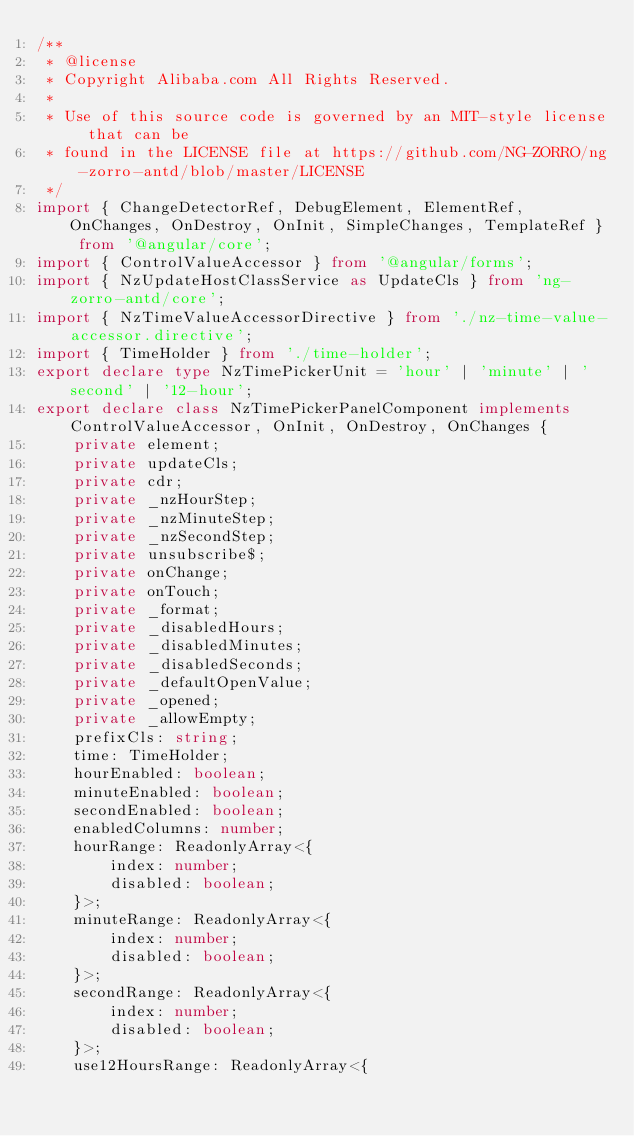<code> <loc_0><loc_0><loc_500><loc_500><_TypeScript_>/**
 * @license
 * Copyright Alibaba.com All Rights Reserved.
 *
 * Use of this source code is governed by an MIT-style license that can be
 * found in the LICENSE file at https://github.com/NG-ZORRO/ng-zorro-antd/blob/master/LICENSE
 */
import { ChangeDetectorRef, DebugElement, ElementRef, OnChanges, OnDestroy, OnInit, SimpleChanges, TemplateRef } from '@angular/core';
import { ControlValueAccessor } from '@angular/forms';
import { NzUpdateHostClassService as UpdateCls } from 'ng-zorro-antd/core';
import { NzTimeValueAccessorDirective } from './nz-time-value-accessor.directive';
import { TimeHolder } from './time-holder';
export declare type NzTimePickerUnit = 'hour' | 'minute' | 'second' | '12-hour';
export declare class NzTimePickerPanelComponent implements ControlValueAccessor, OnInit, OnDestroy, OnChanges {
    private element;
    private updateCls;
    private cdr;
    private _nzHourStep;
    private _nzMinuteStep;
    private _nzSecondStep;
    private unsubscribe$;
    private onChange;
    private onTouch;
    private _format;
    private _disabledHours;
    private _disabledMinutes;
    private _disabledSeconds;
    private _defaultOpenValue;
    private _opened;
    private _allowEmpty;
    prefixCls: string;
    time: TimeHolder;
    hourEnabled: boolean;
    minuteEnabled: boolean;
    secondEnabled: boolean;
    enabledColumns: number;
    hourRange: ReadonlyArray<{
        index: number;
        disabled: boolean;
    }>;
    minuteRange: ReadonlyArray<{
        index: number;
        disabled: boolean;
    }>;
    secondRange: ReadonlyArray<{
        index: number;
        disabled: boolean;
    }>;
    use12HoursRange: ReadonlyArray<{</code> 